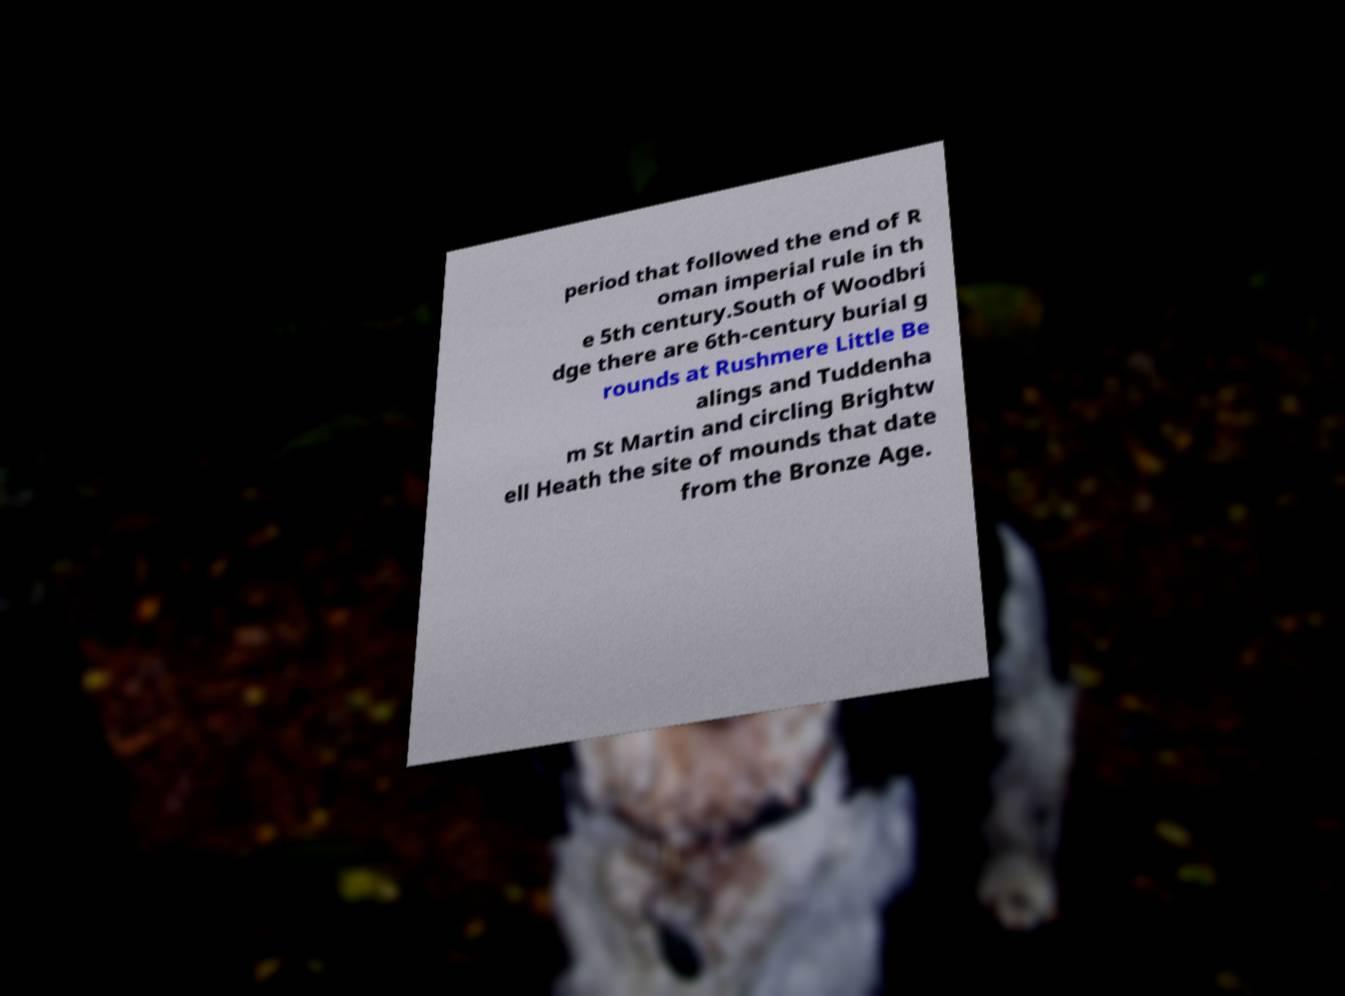For documentation purposes, I need the text within this image transcribed. Could you provide that? period that followed the end of R oman imperial rule in th e 5th century.South of Woodbri dge there are 6th-century burial g rounds at Rushmere Little Be alings and Tuddenha m St Martin and circling Brightw ell Heath the site of mounds that date from the Bronze Age. 